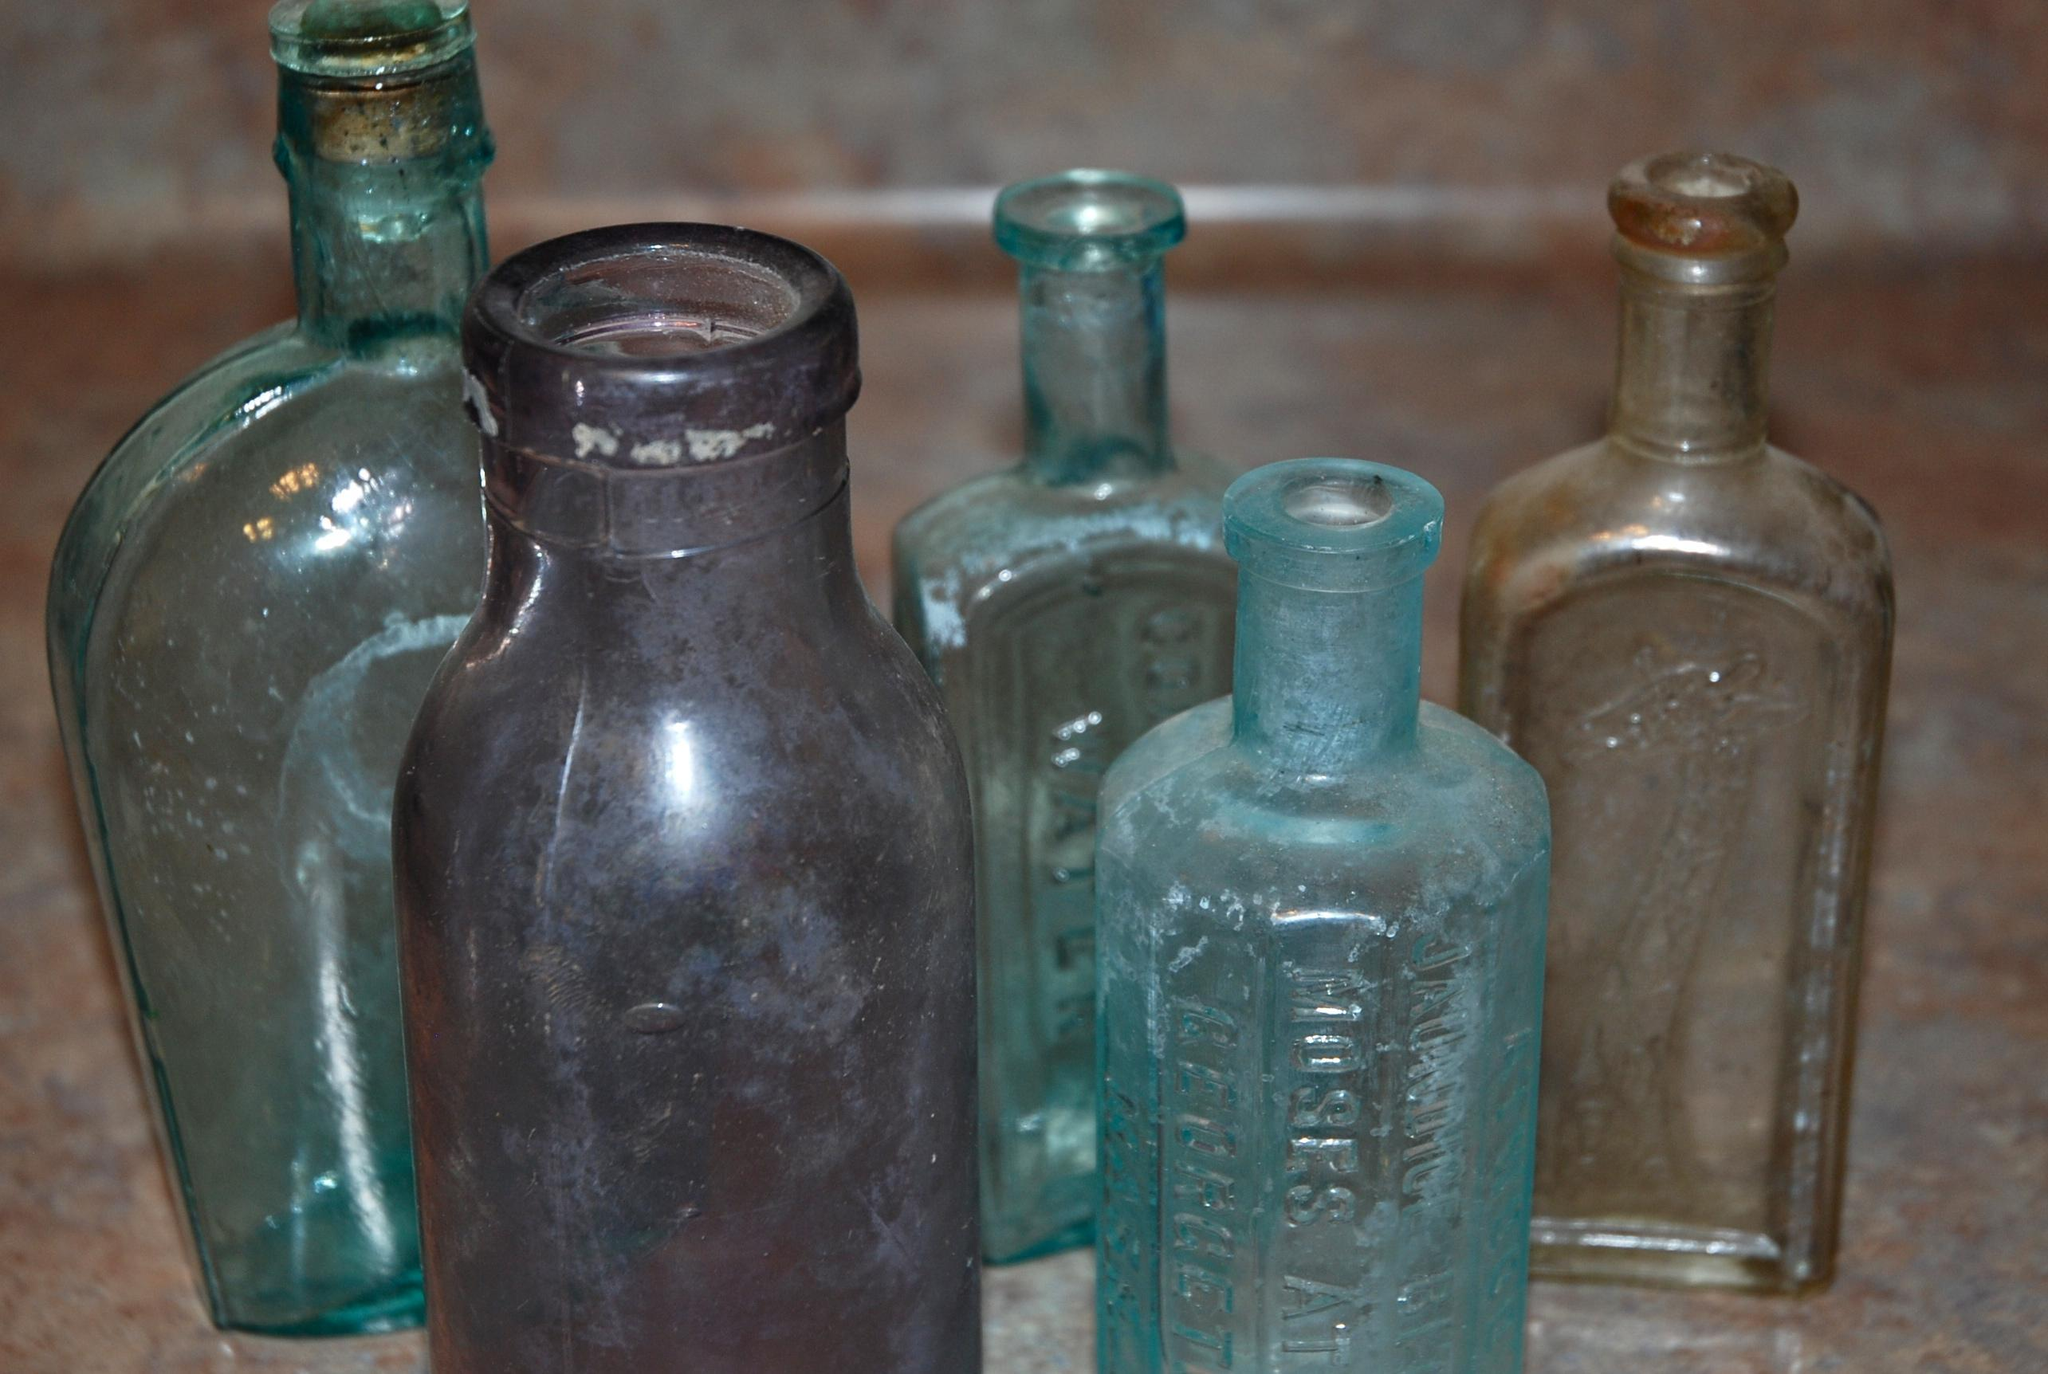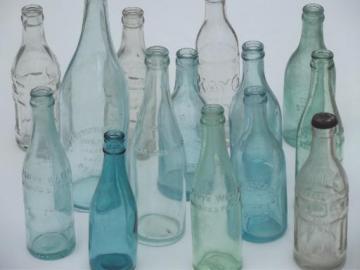The first image is the image on the left, the second image is the image on the right. For the images displayed, is the sentence "One image features only upright bottles in a variety of shapes, sizes and colors, and includes at least one bottle with a paper label." factually correct? Answer yes or no. No. 